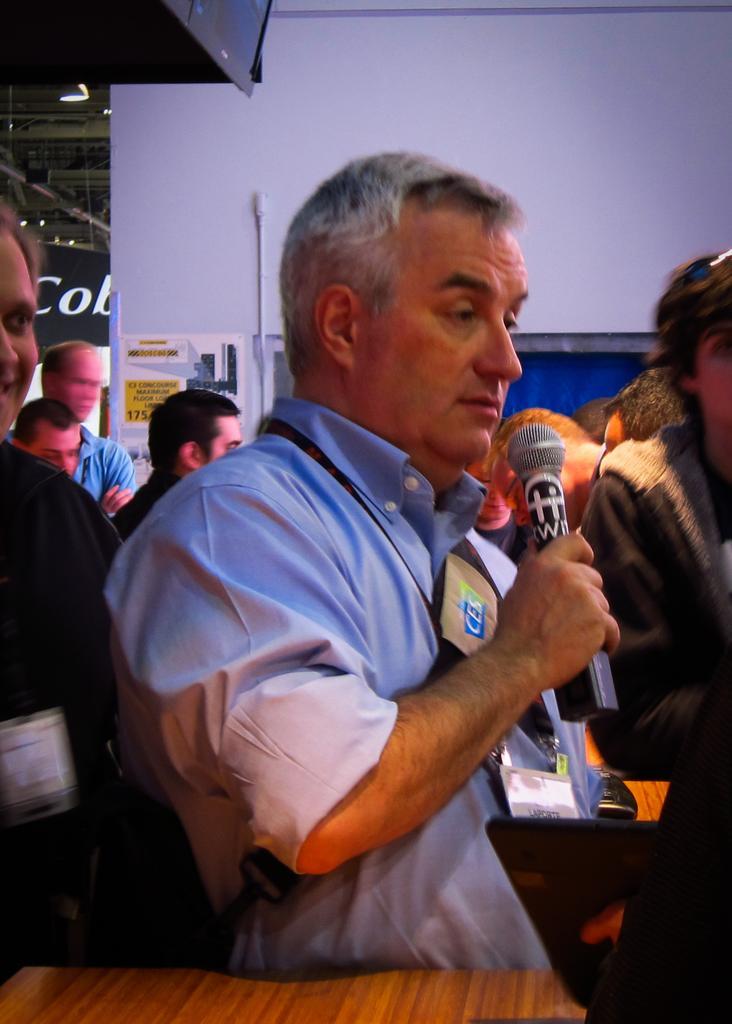How would you summarize this image in a sentence or two? In this picture, there is a table which is in yellow color, In the middle there is a man who is standing and he is holding a microphone, In the background there are some people standing and there is a white color wall. 